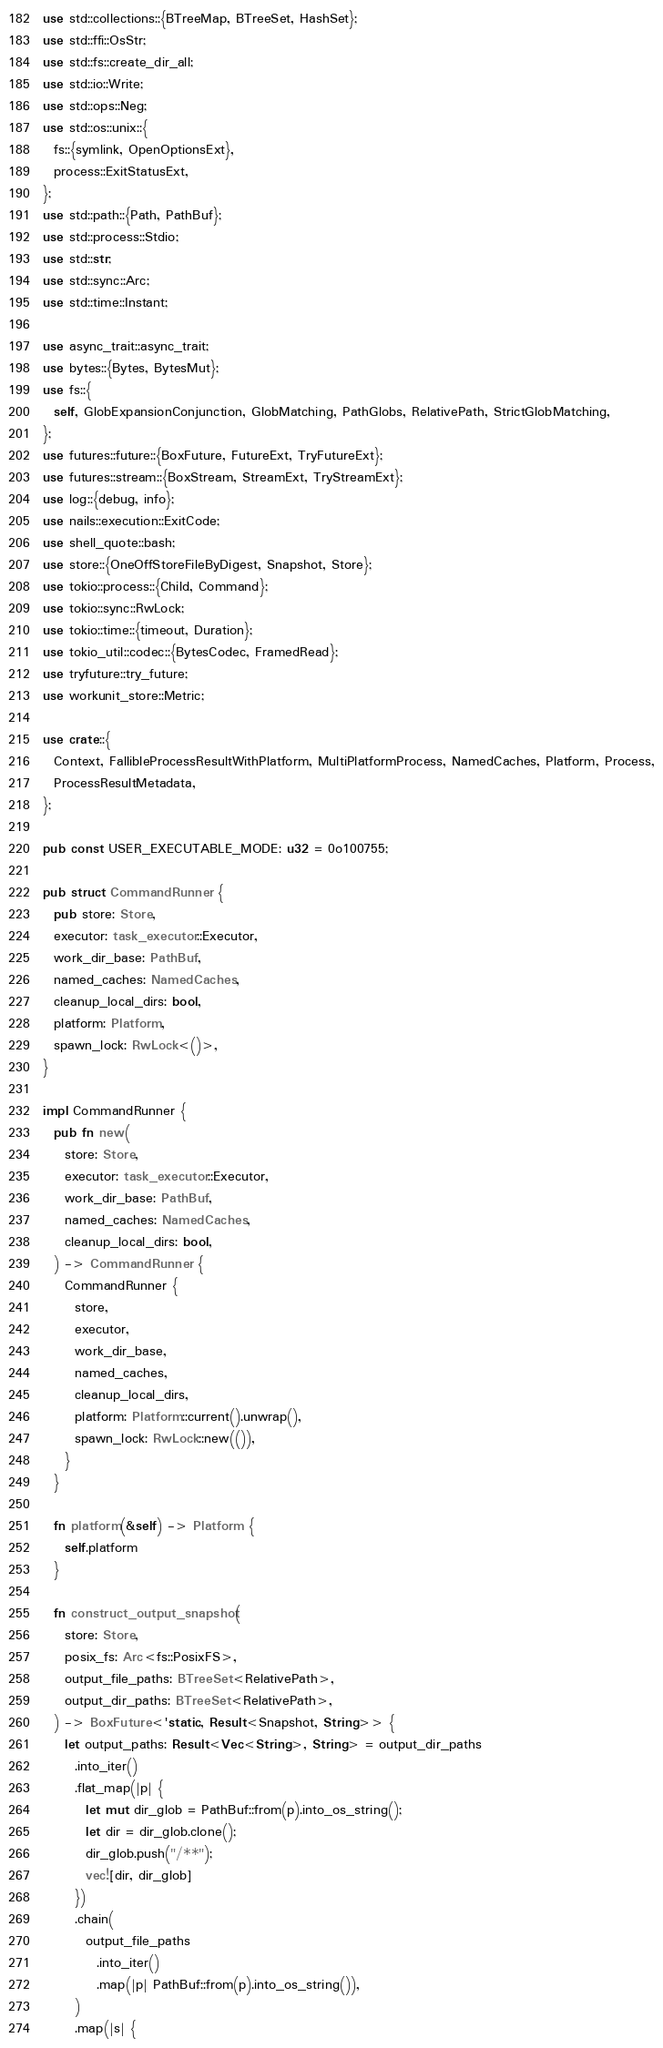Convert code to text. <code><loc_0><loc_0><loc_500><loc_500><_Rust_>use std::collections::{BTreeMap, BTreeSet, HashSet};
use std::ffi::OsStr;
use std::fs::create_dir_all;
use std::io::Write;
use std::ops::Neg;
use std::os::unix::{
  fs::{symlink, OpenOptionsExt},
  process::ExitStatusExt,
};
use std::path::{Path, PathBuf};
use std::process::Stdio;
use std::str;
use std::sync::Arc;
use std::time::Instant;

use async_trait::async_trait;
use bytes::{Bytes, BytesMut};
use fs::{
  self, GlobExpansionConjunction, GlobMatching, PathGlobs, RelativePath, StrictGlobMatching,
};
use futures::future::{BoxFuture, FutureExt, TryFutureExt};
use futures::stream::{BoxStream, StreamExt, TryStreamExt};
use log::{debug, info};
use nails::execution::ExitCode;
use shell_quote::bash;
use store::{OneOffStoreFileByDigest, Snapshot, Store};
use tokio::process::{Child, Command};
use tokio::sync::RwLock;
use tokio::time::{timeout, Duration};
use tokio_util::codec::{BytesCodec, FramedRead};
use tryfuture::try_future;
use workunit_store::Metric;

use crate::{
  Context, FallibleProcessResultWithPlatform, MultiPlatformProcess, NamedCaches, Platform, Process,
  ProcessResultMetadata,
};

pub const USER_EXECUTABLE_MODE: u32 = 0o100755;

pub struct CommandRunner {
  pub store: Store,
  executor: task_executor::Executor,
  work_dir_base: PathBuf,
  named_caches: NamedCaches,
  cleanup_local_dirs: bool,
  platform: Platform,
  spawn_lock: RwLock<()>,
}

impl CommandRunner {
  pub fn new(
    store: Store,
    executor: task_executor::Executor,
    work_dir_base: PathBuf,
    named_caches: NamedCaches,
    cleanup_local_dirs: bool,
  ) -> CommandRunner {
    CommandRunner {
      store,
      executor,
      work_dir_base,
      named_caches,
      cleanup_local_dirs,
      platform: Platform::current().unwrap(),
      spawn_lock: RwLock::new(()),
    }
  }

  fn platform(&self) -> Platform {
    self.platform
  }

  fn construct_output_snapshot(
    store: Store,
    posix_fs: Arc<fs::PosixFS>,
    output_file_paths: BTreeSet<RelativePath>,
    output_dir_paths: BTreeSet<RelativePath>,
  ) -> BoxFuture<'static, Result<Snapshot, String>> {
    let output_paths: Result<Vec<String>, String> = output_dir_paths
      .into_iter()
      .flat_map(|p| {
        let mut dir_glob = PathBuf::from(p).into_os_string();
        let dir = dir_glob.clone();
        dir_glob.push("/**");
        vec![dir, dir_glob]
      })
      .chain(
        output_file_paths
          .into_iter()
          .map(|p| PathBuf::from(p).into_os_string()),
      )
      .map(|s| {</code> 